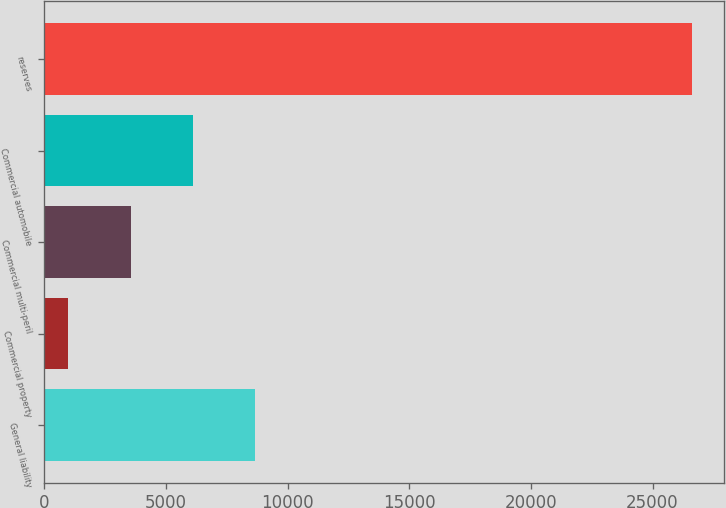Convert chart to OTSL. <chart><loc_0><loc_0><loc_500><loc_500><bar_chart><fcel>General liability<fcel>Commercial property<fcel>Commercial multi-peril<fcel>Commercial automobile<fcel>reserves<nl><fcel>8676.2<fcel>992<fcel>3553.4<fcel>6114.8<fcel>26606<nl></chart> 